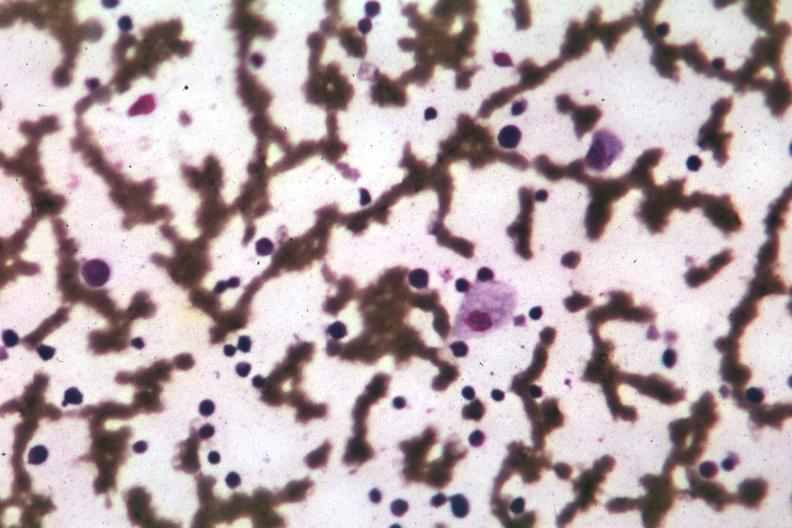what is present?
Answer the question using a single word or phrase. Bone marrow 